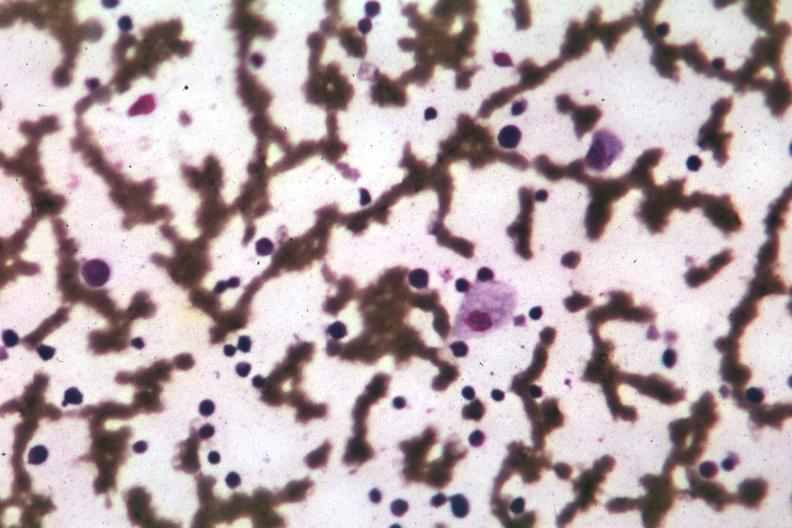what is present?
Answer the question using a single word or phrase. Bone marrow 